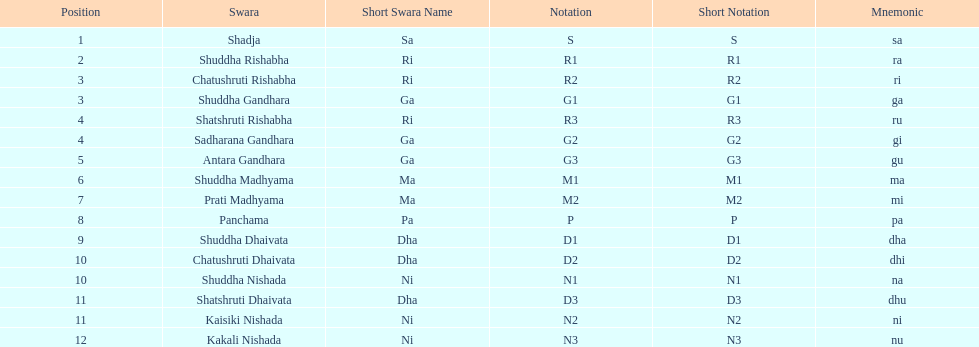What is the name of the swara that holds the first position? Shadja. 